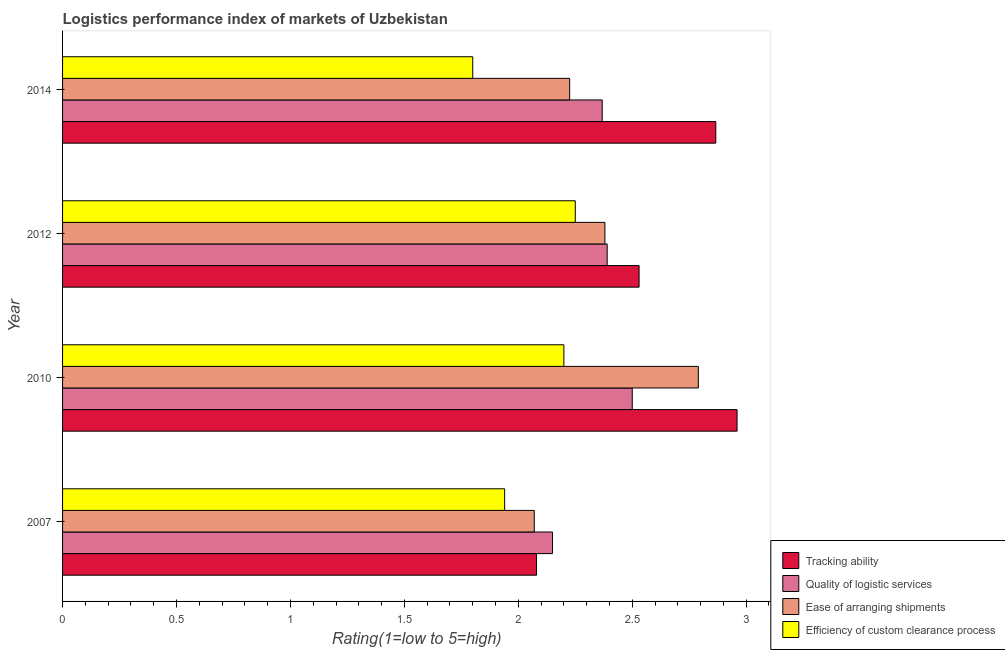How many groups of bars are there?
Your answer should be very brief. 4. Are the number of bars on each tick of the Y-axis equal?
Make the answer very short. Yes. How many bars are there on the 1st tick from the top?
Offer a terse response. 4. Across all years, what is the maximum lpi rating of quality of logistic services?
Ensure brevity in your answer.  2.5. Across all years, what is the minimum lpi rating of efficiency of custom clearance process?
Your response must be concise. 1.8. In which year was the lpi rating of quality of logistic services maximum?
Ensure brevity in your answer.  2010. In which year was the lpi rating of efficiency of custom clearance process minimum?
Your answer should be compact. 2014. What is the total lpi rating of efficiency of custom clearance process in the graph?
Make the answer very short. 8.19. What is the difference between the lpi rating of tracking ability in 2012 and that in 2014?
Offer a terse response. -0.34. What is the difference between the lpi rating of ease of arranging shipments in 2014 and the lpi rating of quality of logistic services in 2007?
Your answer should be compact. 0.08. What is the average lpi rating of efficiency of custom clearance process per year?
Keep it short and to the point. 2.05. In the year 2014, what is the difference between the lpi rating of ease of arranging shipments and lpi rating of efficiency of custom clearance process?
Keep it short and to the point. 0.42. What is the ratio of the lpi rating of efficiency of custom clearance process in 2007 to that in 2012?
Provide a succinct answer. 0.86. Is the difference between the lpi rating of efficiency of custom clearance process in 2012 and 2014 greater than the difference between the lpi rating of tracking ability in 2012 and 2014?
Your answer should be very brief. Yes. What is the difference between the highest and the second highest lpi rating of ease of arranging shipments?
Keep it short and to the point. 0.41. What is the difference between the highest and the lowest lpi rating of ease of arranging shipments?
Your answer should be compact. 0.72. In how many years, is the lpi rating of tracking ability greater than the average lpi rating of tracking ability taken over all years?
Your answer should be very brief. 2. Is the sum of the lpi rating of ease of arranging shipments in 2012 and 2014 greater than the maximum lpi rating of quality of logistic services across all years?
Keep it short and to the point. Yes. What does the 3rd bar from the top in 2010 represents?
Ensure brevity in your answer.  Quality of logistic services. What does the 4th bar from the bottom in 2012 represents?
Give a very brief answer. Efficiency of custom clearance process. Is it the case that in every year, the sum of the lpi rating of tracking ability and lpi rating of quality of logistic services is greater than the lpi rating of ease of arranging shipments?
Offer a very short reply. Yes. How many bars are there?
Provide a succinct answer. 16. How many years are there in the graph?
Your answer should be compact. 4. What is the difference between two consecutive major ticks on the X-axis?
Ensure brevity in your answer.  0.5. Are the values on the major ticks of X-axis written in scientific E-notation?
Provide a succinct answer. No. Does the graph contain grids?
Give a very brief answer. No. Where does the legend appear in the graph?
Keep it short and to the point. Bottom right. How many legend labels are there?
Your response must be concise. 4. What is the title of the graph?
Your answer should be very brief. Logistics performance index of markets of Uzbekistan. What is the label or title of the X-axis?
Your response must be concise. Rating(1=low to 5=high). What is the label or title of the Y-axis?
Make the answer very short. Year. What is the Rating(1=low to 5=high) of Tracking ability in 2007?
Ensure brevity in your answer.  2.08. What is the Rating(1=low to 5=high) in Quality of logistic services in 2007?
Your answer should be compact. 2.15. What is the Rating(1=low to 5=high) of Ease of arranging shipments in 2007?
Provide a short and direct response. 2.07. What is the Rating(1=low to 5=high) of Efficiency of custom clearance process in 2007?
Ensure brevity in your answer.  1.94. What is the Rating(1=low to 5=high) in Tracking ability in 2010?
Keep it short and to the point. 2.96. What is the Rating(1=low to 5=high) in Quality of logistic services in 2010?
Your answer should be very brief. 2.5. What is the Rating(1=low to 5=high) of Ease of arranging shipments in 2010?
Ensure brevity in your answer.  2.79. What is the Rating(1=low to 5=high) in Efficiency of custom clearance process in 2010?
Your response must be concise. 2.2. What is the Rating(1=low to 5=high) in Tracking ability in 2012?
Your answer should be very brief. 2.53. What is the Rating(1=low to 5=high) in Quality of logistic services in 2012?
Ensure brevity in your answer.  2.39. What is the Rating(1=low to 5=high) of Ease of arranging shipments in 2012?
Make the answer very short. 2.38. What is the Rating(1=low to 5=high) of Efficiency of custom clearance process in 2012?
Provide a short and direct response. 2.25. What is the Rating(1=low to 5=high) in Tracking ability in 2014?
Provide a short and direct response. 2.87. What is the Rating(1=low to 5=high) in Quality of logistic services in 2014?
Your answer should be compact. 2.37. What is the Rating(1=low to 5=high) of Ease of arranging shipments in 2014?
Your answer should be compact. 2.23. What is the Rating(1=low to 5=high) in Efficiency of custom clearance process in 2014?
Ensure brevity in your answer.  1.8. Across all years, what is the maximum Rating(1=low to 5=high) in Tracking ability?
Ensure brevity in your answer.  2.96. Across all years, what is the maximum Rating(1=low to 5=high) in Quality of logistic services?
Your response must be concise. 2.5. Across all years, what is the maximum Rating(1=low to 5=high) of Ease of arranging shipments?
Keep it short and to the point. 2.79. Across all years, what is the maximum Rating(1=low to 5=high) of Efficiency of custom clearance process?
Offer a very short reply. 2.25. Across all years, what is the minimum Rating(1=low to 5=high) of Tracking ability?
Provide a succinct answer. 2.08. Across all years, what is the minimum Rating(1=low to 5=high) in Quality of logistic services?
Offer a very short reply. 2.15. Across all years, what is the minimum Rating(1=low to 5=high) in Ease of arranging shipments?
Provide a short and direct response. 2.07. What is the total Rating(1=low to 5=high) of Tracking ability in the graph?
Your answer should be very brief. 10.44. What is the total Rating(1=low to 5=high) in Quality of logistic services in the graph?
Your response must be concise. 9.41. What is the total Rating(1=low to 5=high) in Ease of arranging shipments in the graph?
Your answer should be compact. 9.47. What is the total Rating(1=low to 5=high) in Efficiency of custom clearance process in the graph?
Provide a succinct answer. 8.19. What is the difference between the Rating(1=low to 5=high) of Tracking ability in 2007 and that in 2010?
Your answer should be very brief. -0.88. What is the difference between the Rating(1=low to 5=high) of Quality of logistic services in 2007 and that in 2010?
Give a very brief answer. -0.35. What is the difference between the Rating(1=low to 5=high) of Ease of arranging shipments in 2007 and that in 2010?
Provide a succinct answer. -0.72. What is the difference between the Rating(1=low to 5=high) of Efficiency of custom clearance process in 2007 and that in 2010?
Offer a terse response. -0.26. What is the difference between the Rating(1=low to 5=high) in Tracking ability in 2007 and that in 2012?
Provide a short and direct response. -0.45. What is the difference between the Rating(1=low to 5=high) of Quality of logistic services in 2007 and that in 2012?
Provide a succinct answer. -0.24. What is the difference between the Rating(1=low to 5=high) of Ease of arranging shipments in 2007 and that in 2012?
Provide a succinct answer. -0.31. What is the difference between the Rating(1=low to 5=high) in Efficiency of custom clearance process in 2007 and that in 2012?
Keep it short and to the point. -0.31. What is the difference between the Rating(1=low to 5=high) of Tracking ability in 2007 and that in 2014?
Ensure brevity in your answer.  -0.79. What is the difference between the Rating(1=low to 5=high) in Quality of logistic services in 2007 and that in 2014?
Make the answer very short. -0.22. What is the difference between the Rating(1=low to 5=high) of Ease of arranging shipments in 2007 and that in 2014?
Offer a terse response. -0.16. What is the difference between the Rating(1=low to 5=high) of Efficiency of custom clearance process in 2007 and that in 2014?
Your response must be concise. 0.14. What is the difference between the Rating(1=low to 5=high) in Tracking ability in 2010 and that in 2012?
Provide a short and direct response. 0.43. What is the difference between the Rating(1=low to 5=high) in Quality of logistic services in 2010 and that in 2012?
Give a very brief answer. 0.11. What is the difference between the Rating(1=low to 5=high) of Ease of arranging shipments in 2010 and that in 2012?
Your response must be concise. 0.41. What is the difference between the Rating(1=low to 5=high) of Tracking ability in 2010 and that in 2014?
Offer a terse response. 0.09. What is the difference between the Rating(1=low to 5=high) in Quality of logistic services in 2010 and that in 2014?
Ensure brevity in your answer.  0.13. What is the difference between the Rating(1=low to 5=high) in Ease of arranging shipments in 2010 and that in 2014?
Provide a short and direct response. 0.56. What is the difference between the Rating(1=low to 5=high) of Tracking ability in 2012 and that in 2014?
Offer a very short reply. -0.34. What is the difference between the Rating(1=low to 5=high) of Quality of logistic services in 2012 and that in 2014?
Offer a very short reply. 0.02. What is the difference between the Rating(1=low to 5=high) in Ease of arranging shipments in 2012 and that in 2014?
Make the answer very short. 0.15. What is the difference between the Rating(1=low to 5=high) in Efficiency of custom clearance process in 2012 and that in 2014?
Your answer should be compact. 0.45. What is the difference between the Rating(1=low to 5=high) in Tracking ability in 2007 and the Rating(1=low to 5=high) in Quality of logistic services in 2010?
Your response must be concise. -0.42. What is the difference between the Rating(1=low to 5=high) in Tracking ability in 2007 and the Rating(1=low to 5=high) in Ease of arranging shipments in 2010?
Offer a very short reply. -0.71. What is the difference between the Rating(1=low to 5=high) in Tracking ability in 2007 and the Rating(1=low to 5=high) in Efficiency of custom clearance process in 2010?
Offer a terse response. -0.12. What is the difference between the Rating(1=low to 5=high) of Quality of logistic services in 2007 and the Rating(1=low to 5=high) of Ease of arranging shipments in 2010?
Your answer should be compact. -0.64. What is the difference between the Rating(1=low to 5=high) of Ease of arranging shipments in 2007 and the Rating(1=low to 5=high) of Efficiency of custom clearance process in 2010?
Give a very brief answer. -0.13. What is the difference between the Rating(1=low to 5=high) of Tracking ability in 2007 and the Rating(1=low to 5=high) of Quality of logistic services in 2012?
Give a very brief answer. -0.31. What is the difference between the Rating(1=low to 5=high) in Tracking ability in 2007 and the Rating(1=low to 5=high) in Ease of arranging shipments in 2012?
Ensure brevity in your answer.  -0.3. What is the difference between the Rating(1=low to 5=high) in Tracking ability in 2007 and the Rating(1=low to 5=high) in Efficiency of custom clearance process in 2012?
Your answer should be very brief. -0.17. What is the difference between the Rating(1=low to 5=high) in Quality of logistic services in 2007 and the Rating(1=low to 5=high) in Ease of arranging shipments in 2012?
Ensure brevity in your answer.  -0.23. What is the difference between the Rating(1=low to 5=high) in Quality of logistic services in 2007 and the Rating(1=low to 5=high) in Efficiency of custom clearance process in 2012?
Give a very brief answer. -0.1. What is the difference between the Rating(1=low to 5=high) in Ease of arranging shipments in 2007 and the Rating(1=low to 5=high) in Efficiency of custom clearance process in 2012?
Provide a succinct answer. -0.18. What is the difference between the Rating(1=low to 5=high) of Tracking ability in 2007 and the Rating(1=low to 5=high) of Quality of logistic services in 2014?
Ensure brevity in your answer.  -0.29. What is the difference between the Rating(1=low to 5=high) in Tracking ability in 2007 and the Rating(1=low to 5=high) in Ease of arranging shipments in 2014?
Your answer should be very brief. -0.15. What is the difference between the Rating(1=low to 5=high) in Tracking ability in 2007 and the Rating(1=low to 5=high) in Efficiency of custom clearance process in 2014?
Your response must be concise. 0.28. What is the difference between the Rating(1=low to 5=high) in Quality of logistic services in 2007 and the Rating(1=low to 5=high) in Ease of arranging shipments in 2014?
Offer a terse response. -0.08. What is the difference between the Rating(1=low to 5=high) of Ease of arranging shipments in 2007 and the Rating(1=low to 5=high) of Efficiency of custom clearance process in 2014?
Your response must be concise. 0.27. What is the difference between the Rating(1=low to 5=high) of Tracking ability in 2010 and the Rating(1=low to 5=high) of Quality of logistic services in 2012?
Keep it short and to the point. 0.57. What is the difference between the Rating(1=low to 5=high) of Tracking ability in 2010 and the Rating(1=low to 5=high) of Ease of arranging shipments in 2012?
Offer a terse response. 0.58. What is the difference between the Rating(1=low to 5=high) in Tracking ability in 2010 and the Rating(1=low to 5=high) in Efficiency of custom clearance process in 2012?
Offer a terse response. 0.71. What is the difference between the Rating(1=low to 5=high) of Quality of logistic services in 2010 and the Rating(1=low to 5=high) of Ease of arranging shipments in 2012?
Give a very brief answer. 0.12. What is the difference between the Rating(1=low to 5=high) of Ease of arranging shipments in 2010 and the Rating(1=low to 5=high) of Efficiency of custom clearance process in 2012?
Offer a very short reply. 0.54. What is the difference between the Rating(1=low to 5=high) of Tracking ability in 2010 and the Rating(1=low to 5=high) of Quality of logistic services in 2014?
Your answer should be compact. 0.59. What is the difference between the Rating(1=low to 5=high) of Tracking ability in 2010 and the Rating(1=low to 5=high) of Ease of arranging shipments in 2014?
Ensure brevity in your answer.  0.73. What is the difference between the Rating(1=low to 5=high) of Tracking ability in 2010 and the Rating(1=low to 5=high) of Efficiency of custom clearance process in 2014?
Ensure brevity in your answer.  1.16. What is the difference between the Rating(1=low to 5=high) of Quality of logistic services in 2010 and the Rating(1=low to 5=high) of Ease of arranging shipments in 2014?
Offer a very short reply. 0.27. What is the difference between the Rating(1=low to 5=high) in Quality of logistic services in 2010 and the Rating(1=low to 5=high) in Efficiency of custom clearance process in 2014?
Your answer should be compact. 0.7. What is the difference between the Rating(1=low to 5=high) in Tracking ability in 2012 and the Rating(1=low to 5=high) in Quality of logistic services in 2014?
Offer a terse response. 0.16. What is the difference between the Rating(1=low to 5=high) of Tracking ability in 2012 and the Rating(1=low to 5=high) of Ease of arranging shipments in 2014?
Offer a very short reply. 0.3. What is the difference between the Rating(1=low to 5=high) of Tracking ability in 2012 and the Rating(1=low to 5=high) of Efficiency of custom clearance process in 2014?
Keep it short and to the point. 0.73. What is the difference between the Rating(1=low to 5=high) in Quality of logistic services in 2012 and the Rating(1=low to 5=high) in Ease of arranging shipments in 2014?
Offer a terse response. 0.16. What is the difference between the Rating(1=low to 5=high) in Quality of logistic services in 2012 and the Rating(1=low to 5=high) in Efficiency of custom clearance process in 2014?
Your response must be concise. 0.59. What is the difference between the Rating(1=low to 5=high) of Ease of arranging shipments in 2012 and the Rating(1=low to 5=high) of Efficiency of custom clearance process in 2014?
Offer a terse response. 0.58. What is the average Rating(1=low to 5=high) of Tracking ability per year?
Offer a very short reply. 2.61. What is the average Rating(1=low to 5=high) in Quality of logistic services per year?
Offer a very short reply. 2.35. What is the average Rating(1=low to 5=high) in Ease of arranging shipments per year?
Offer a terse response. 2.37. What is the average Rating(1=low to 5=high) in Efficiency of custom clearance process per year?
Your answer should be compact. 2.05. In the year 2007, what is the difference between the Rating(1=low to 5=high) in Tracking ability and Rating(1=low to 5=high) in Quality of logistic services?
Your answer should be very brief. -0.07. In the year 2007, what is the difference between the Rating(1=low to 5=high) of Tracking ability and Rating(1=low to 5=high) of Ease of arranging shipments?
Give a very brief answer. 0.01. In the year 2007, what is the difference between the Rating(1=low to 5=high) of Tracking ability and Rating(1=low to 5=high) of Efficiency of custom clearance process?
Make the answer very short. 0.14. In the year 2007, what is the difference between the Rating(1=low to 5=high) in Quality of logistic services and Rating(1=low to 5=high) in Ease of arranging shipments?
Your answer should be very brief. 0.08. In the year 2007, what is the difference between the Rating(1=low to 5=high) of Quality of logistic services and Rating(1=low to 5=high) of Efficiency of custom clearance process?
Keep it short and to the point. 0.21. In the year 2007, what is the difference between the Rating(1=low to 5=high) of Ease of arranging shipments and Rating(1=low to 5=high) of Efficiency of custom clearance process?
Keep it short and to the point. 0.13. In the year 2010, what is the difference between the Rating(1=low to 5=high) of Tracking ability and Rating(1=low to 5=high) of Quality of logistic services?
Offer a very short reply. 0.46. In the year 2010, what is the difference between the Rating(1=low to 5=high) in Tracking ability and Rating(1=low to 5=high) in Ease of arranging shipments?
Provide a short and direct response. 0.17. In the year 2010, what is the difference between the Rating(1=low to 5=high) of Tracking ability and Rating(1=low to 5=high) of Efficiency of custom clearance process?
Give a very brief answer. 0.76. In the year 2010, what is the difference between the Rating(1=low to 5=high) of Quality of logistic services and Rating(1=low to 5=high) of Ease of arranging shipments?
Offer a terse response. -0.29. In the year 2010, what is the difference between the Rating(1=low to 5=high) of Ease of arranging shipments and Rating(1=low to 5=high) of Efficiency of custom clearance process?
Offer a terse response. 0.59. In the year 2012, what is the difference between the Rating(1=low to 5=high) in Tracking ability and Rating(1=low to 5=high) in Quality of logistic services?
Your response must be concise. 0.14. In the year 2012, what is the difference between the Rating(1=low to 5=high) in Tracking ability and Rating(1=low to 5=high) in Efficiency of custom clearance process?
Make the answer very short. 0.28. In the year 2012, what is the difference between the Rating(1=low to 5=high) of Quality of logistic services and Rating(1=low to 5=high) of Ease of arranging shipments?
Your answer should be compact. 0.01. In the year 2012, what is the difference between the Rating(1=low to 5=high) in Quality of logistic services and Rating(1=low to 5=high) in Efficiency of custom clearance process?
Make the answer very short. 0.14. In the year 2012, what is the difference between the Rating(1=low to 5=high) in Ease of arranging shipments and Rating(1=low to 5=high) in Efficiency of custom clearance process?
Offer a very short reply. 0.13. In the year 2014, what is the difference between the Rating(1=low to 5=high) of Tracking ability and Rating(1=low to 5=high) of Quality of logistic services?
Keep it short and to the point. 0.5. In the year 2014, what is the difference between the Rating(1=low to 5=high) of Tracking ability and Rating(1=low to 5=high) of Ease of arranging shipments?
Provide a short and direct response. 0.64. In the year 2014, what is the difference between the Rating(1=low to 5=high) of Tracking ability and Rating(1=low to 5=high) of Efficiency of custom clearance process?
Give a very brief answer. 1.07. In the year 2014, what is the difference between the Rating(1=low to 5=high) in Quality of logistic services and Rating(1=low to 5=high) in Ease of arranging shipments?
Provide a succinct answer. 0.14. In the year 2014, what is the difference between the Rating(1=low to 5=high) in Quality of logistic services and Rating(1=low to 5=high) in Efficiency of custom clearance process?
Provide a succinct answer. 0.57. In the year 2014, what is the difference between the Rating(1=low to 5=high) in Ease of arranging shipments and Rating(1=low to 5=high) in Efficiency of custom clearance process?
Offer a very short reply. 0.43. What is the ratio of the Rating(1=low to 5=high) in Tracking ability in 2007 to that in 2010?
Provide a succinct answer. 0.7. What is the ratio of the Rating(1=low to 5=high) of Quality of logistic services in 2007 to that in 2010?
Offer a terse response. 0.86. What is the ratio of the Rating(1=low to 5=high) in Ease of arranging shipments in 2007 to that in 2010?
Your response must be concise. 0.74. What is the ratio of the Rating(1=low to 5=high) in Efficiency of custom clearance process in 2007 to that in 2010?
Make the answer very short. 0.88. What is the ratio of the Rating(1=low to 5=high) of Tracking ability in 2007 to that in 2012?
Offer a very short reply. 0.82. What is the ratio of the Rating(1=low to 5=high) of Quality of logistic services in 2007 to that in 2012?
Your answer should be compact. 0.9. What is the ratio of the Rating(1=low to 5=high) in Ease of arranging shipments in 2007 to that in 2012?
Your response must be concise. 0.87. What is the ratio of the Rating(1=low to 5=high) in Efficiency of custom clearance process in 2007 to that in 2012?
Keep it short and to the point. 0.86. What is the ratio of the Rating(1=low to 5=high) of Tracking ability in 2007 to that in 2014?
Your answer should be very brief. 0.73. What is the ratio of the Rating(1=low to 5=high) in Quality of logistic services in 2007 to that in 2014?
Provide a succinct answer. 0.91. What is the ratio of the Rating(1=low to 5=high) in Ease of arranging shipments in 2007 to that in 2014?
Your response must be concise. 0.93. What is the ratio of the Rating(1=low to 5=high) in Efficiency of custom clearance process in 2007 to that in 2014?
Offer a terse response. 1.08. What is the ratio of the Rating(1=low to 5=high) in Tracking ability in 2010 to that in 2012?
Your response must be concise. 1.17. What is the ratio of the Rating(1=low to 5=high) of Quality of logistic services in 2010 to that in 2012?
Your response must be concise. 1.05. What is the ratio of the Rating(1=low to 5=high) of Ease of arranging shipments in 2010 to that in 2012?
Keep it short and to the point. 1.17. What is the ratio of the Rating(1=low to 5=high) in Efficiency of custom clearance process in 2010 to that in 2012?
Ensure brevity in your answer.  0.98. What is the ratio of the Rating(1=low to 5=high) of Tracking ability in 2010 to that in 2014?
Provide a short and direct response. 1.03. What is the ratio of the Rating(1=low to 5=high) in Quality of logistic services in 2010 to that in 2014?
Ensure brevity in your answer.  1.06. What is the ratio of the Rating(1=low to 5=high) in Ease of arranging shipments in 2010 to that in 2014?
Offer a very short reply. 1.25. What is the ratio of the Rating(1=low to 5=high) of Efficiency of custom clearance process in 2010 to that in 2014?
Your answer should be compact. 1.22. What is the ratio of the Rating(1=low to 5=high) in Tracking ability in 2012 to that in 2014?
Give a very brief answer. 0.88. What is the ratio of the Rating(1=low to 5=high) in Quality of logistic services in 2012 to that in 2014?
Give a very brief answer. 1.01. What is the ratio of the Rating(1=low to 5=high) in Ease of arranging shipments in 2012 to that in 2014?
Keep it short and to the point. 1.07. What is the ratio of the Rating(1=low to 5=high) in Efficiency of custom clearance process in 2012 to that in 2014?
Offer a very short reply. 1.25. What is the difference between the highest and the second highest Rating(1=low to 5=high) of Tracking ability?
Your answer should be very brief. 0.09. What is the difference between the highest and the second highest Rating(1=low to 5=high) in Quality of logistic services?
Your response must be concise. 0.11. What is the difference between the highest and the second highest Rating(1=low to 5=high) of Ease of arranging shipments?
Make the answer very short. 0.41. What is the difference between the highest and the second highest Rating(1=low to 5=high) of Efficiency of custom clearance process?
Your answer should be very brief. 0.05. What is the difference between the highest and the lowest Rating(1=low to 5=high) of Tracking ability?
Offer a very short reply. 0.88. What is the difference between the highest and the lowest Rating(1=low to 5=high) of Ease of arranging shipments?
Offer a very short reply. 0.72. What is the difference between the highest and the lowest Rating(1=low to 5=high) in Efficiency of custom clearance process?
Your answer should be compact. 0.45. 